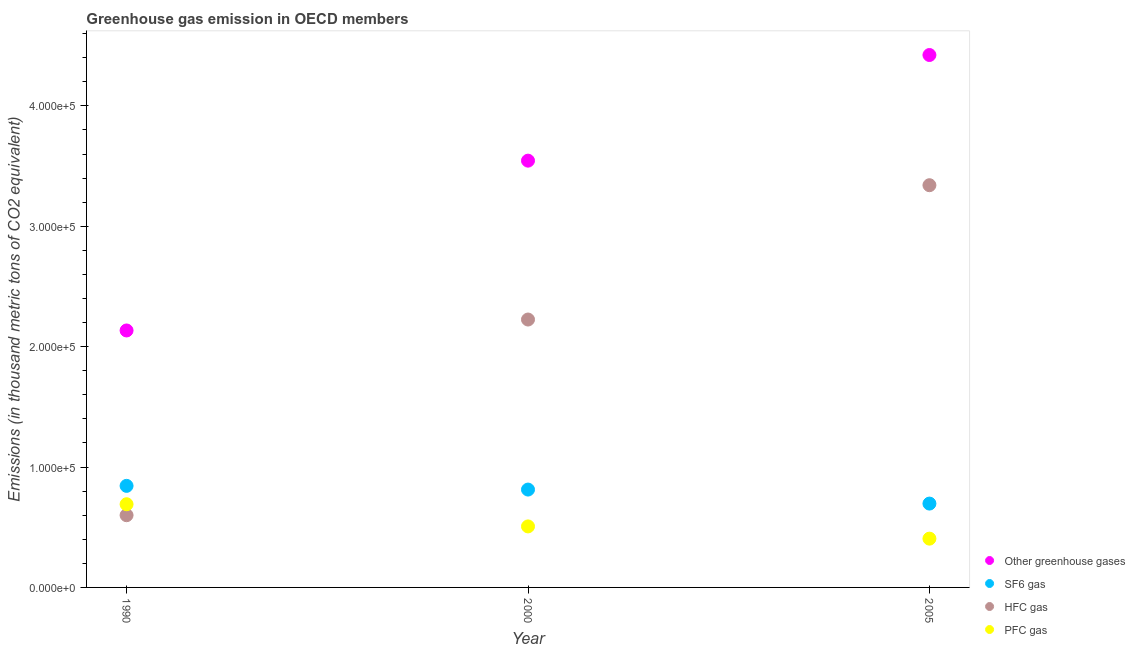What is the emission of greenhouse gases in 2000?
Your answer should be compact. 3.54e+05. Across all years, what is the maximum emission of greenhouse gases?
Your response must be concise. 4.42e+05. Across all years, what is the minimum emission of greenhouse gases?
Provide a succinct answer. 2.13e+05. In which year was the emission of pfc gas maximum?
Offer a terse response. 1990. What is the total emission of hfc gas in the graph?
Provide a succinct answer. 6.17e+05. What is the difference between the emission of hfc gas in 2000 and that in 2005?
Give a very brief answer. -1.12e+05. What is the difference between the emission of sf6 gas in 1990 and the emission of greenhouse gases in 2005?
Your answer should be very brief. -3.58e+05. What is the average emission of greenhouse gases per year?
Offer a terse response. 3.37e+05. In the year 1990, what is the difference between the emission of pfc gas and emission of hfc gas?
Provide a succinct answer. 9114.4. In how many years, is the emission of greenhouse gases greater than 280000 thousand metric tons?
Your answer should be compact. 2. What is the ratio of the emission of pfc gas in 1990 to that in 2005?
Offer a very short reply. 1.71. Is the difference between the emission of greenhouse gases in 1990 and 2005 greater than the difference between the emission of pfc gas in 1990 and 2005?
Your answer should be compact. No. What is the difference between the highest and the second highest emission of greenhouse gases?
Offer a very short reply. 8.78e+04. What is the difference between the highest and the lowest emission of greenhouse gases?
Your answer should be compact. 2.29e+05. Is it the case that in every year, the sum of the emission of greenhouse gases and emission of sf6 gas is greater than the sum of emission of pfc gas and emission of hfc gas?
Your response must be concise. Yes. How many dotlines are there?
Ensure brevity in your answer.  4. How many years are there in the graph?
Provide a succinct answer. 3. Are the values on the major ticks of Y-axis written in scientific E-notation?
Your answer should be very brief. Yes. Does the graph contain any zero values?
Ensure brevity in your answer.  No. Where does the legend appear in the graph?
Your answer should be very brief. Bottom right. What is the title of the graph?
Your answer should be very brief. Greenhouse gas emission in OECD members. Does "Methodology assessment" appear as one of the legend labels in the graph?
Keep it short and to the point. No. What is the label or title of the X-axis?
Make the answer very short. Year. What is the label or title of the Y-axis?
Make the answer very short. Emissions (in thousand metric tons of CO2 equivalent). What is the Emissions (in thousand metric tons of CO2 equivalent) in Other greenhouse gases in 1990?
Ensure brevity in your answer.  2.13e+05. What is the Emissions (in thousand metric tons of CO2 equivalent) in SF6 gas in 1990?
Make the answer very short. 8.44e+04. What is the Emissions (in thousand metric tons of CO2 equivalent) of HFC gas in 1990?
Provide a short and direct response. 6.00e+04. What is the Emissions (in thousand metric tons of CO2 equivalent) in PFC gas in 1990?
Ensure brevity in your answer.  6.91e+04. What is the Emissions (in thousand metric tons of CO2 equivalent) of Other greenhouse gases in 2000?
Give a very brief answer. 3.54e+05. What is the Emissions (in thousand metric tons of CO2 equivalent) of SF6 gas in 2000?
Keep it short and to the point. 8.13e+04. What is the Emissions (in thousand metric tons of CO2 equivalent) in HFC gas in 2000?
Offer a terse response. 2.23e+05. What is the Emissions (in thousand metric tons of CO2 equivalent) of PFC gas in 2000?
Keep it short and to the point. 5.07e+04. What is the Emissions (in thousand metric tons of CO2 equivalent) of Other greenhouse gases in 2005?
Offer a terse response. 4.42e+05. What is the Emissions (in thousand metric tons of CO2 equivalent) in SF6 gas in 2005?
Provide a short and direct response. 6.96e+04. What is the Emissions (in thousand metric tons of CO2 equivalent) in HFC gas in 2005?
Offer a very short reply. 3.34e+05. What is the Emissions (in thousand metric tons of CO2 equivalent) in PFC gas in 2005?
Make the answer very short. 4.05e+04. Across all years, what is the maximum Emissions (in thousand metric tons of CO2 equivalent) in Other greenhouse gases?
Make the answer very short. 4.42e+05. Across all years, what is the maximum Emissions (in thousand metric tons of CO2 equivalent) of SF6 gas?
Your response must be concise. 8.44e+04. Across all years, what is the maximum Emissions (in thousand metric tons of CO2 equivalent) in HFC gas?
Your answer should be compact. 3.34e+05. Across all years, what is the maximum Emissions (in thousand metric tons of CO2 equivalent) in PFC gas?
Keep it short and to the point. 6.91e+04. Across all years, what is the minimum Emissions (in thousand metric tons of CO2 equivalent) of Other greenhouse gases?
Provide a succinct answer. 2.13e+05. Across all years, what is the minimum Emissions (in thousand metric tons of CO2 equivalent) in SF6 gas?
Your answer should be compact. 6.96e+04. Across all years, what is the minimum Emissions (in thousand metric tons of CO2 equivalent) in HFC gas?
Provide a succinct answer. 6.00e+04. Across all years, what is the minimum Emissions (in thousand metric tons of CO2 equivalent) in PFC gas?
Your answer should be compact. 4.05e+04. What is the total Emissions (in thousand metric tons of CO2 equivalent) of Other greenhouse gases in the graph?
Your answer should be compact. 1.01e+06. What is the total Emissions (in thousand metric tons of CO2 equivalent) of SF6 gas in the graph?
Make the answer very short. 2.35e+05. What is the total Emissions (in thousand metric tons of CO2 equivalent) of HFC gas in the graph?
Your answer should be very brief. 6.17e+05. What is the total Emissions (in thousand metric tons of CO2 equivalent) of PFC gas in the graph?
Offer a very short reply. 1.60e+05. What is the difference between the Emissions (in thousand metric tons of CO2 equivalent) of Other greenhouse gases in 1990 and that in 2000?
Ensure brevity in your answer.  -1.41e+05. What is the difference between the Emissions (in thousand metric tons of CO2 equivalent) of SF6 gas in 1990 and that in 2000?
Offer a terse response. 3071.7. What is the difference between the Emissions (in thousand metric tons of CO2 equivalent) in HFC gas in 1990 and that in 2000?
Ensure brevity in your answer.  -1.63e+05. What is the difference between the Emissions (in thousand metric tons of CO2 equivalent) in PFC gas in 1990 and that in 2000?
Provide a succinct answer. 1.84e+04. What is the difference between the Emissions (in thousand metric tons of CO2 equivalent) in Other greenhouse gases in 1990 and that in 2005?
Your answer should be very brief. -2.29e+05. What is the difference between the Emissions (in thousand metric tons of CO2 equivalent) of SF6 gas in 1990 and that in 2005?
Your response must be concise. 1.47e+04. What is the difference between the Emissions (in thousand metric tons of CO2 equivalent) in HFC gas in 1990 and that in 2005?
Make the answer very short. -2.74e+05. What is the difference between the Emissions (in thousand metric tons of CO2 equivalent) in PFC gas in 1990 and that in 2005?
Give a very brief answer. 2.86e+04. What is the difference between the Emissions (in thousand metric tons of CO2 equivalent) of Other greenhouse gases in 2000 and that in 2005?
Provide a succinct answer. -8.78e+04. What is the difference between the Emissions (in thousand metric tons of CO2 equivalent) of SF6 gas in 2000 and that in 2005?
Your response must be concise. 1.16e+04. What is the difference between the Emissions (in thousand metric tons of CO2 equivalent) in HFC gas in 2000 and that in 2005?
Your answer should be very brief. -1.12e+05. What is the difference between the Emissions (in thousand metric tons of CO2 equivalent) in PFC gas in 2000 and that in 2005?
Ensure brevity in your answer.  1.02e+04. What is the difference between the Emissions (in thousand metric tons of CO2 equivalent) in Other greenhouse gases in 1990 and the Emissions (in thousand metric tons of CO2 equivalent) in SF6 gas in 2000?
Your answer should be compact. 1.32e+05. What is the difference between the Emissions (in thousand metric tons of CO2 equivalent) of Other greenhouse gases in 1990 and the Emissions (in thousand metric tons of CO2 equivalent) of HFC gas in 2000?
Offer a terse response. -9085.8. What is the difference between the Emissions (in thousand metric tons of CO2 equivalent) of Other greenhouse gases in 1990 and the Emissions (in thousand metric tons of CO2 equivalent) of PFC gas in 2000?
Make the answer very short. 1.63e+05. What is the difference between the Emissions (in thousand metric tons of CO2 equivalent) in SF6 gas in 1990 and the Emissions (in thousand metric tons of CO2 equivalent) in HFC gas in 2000?
Ensure brevity in your answer.  -1.38e+05. What is the difference between the Emissions (in thousand metric tons of CO2 equivalent) of SF6 gas in 1990 and the Emissions (in thousand metric tons of CO2 equivalent) of PFC gas in 2000?
Give a very brief answer. 3.37e+04. What is the difference between the Emissions (in thousand metric tons of CO2 equivalent) in HFC gas in 1990 and the Emissions (in thousand metric tons of CO2 equivalent) in PFC gas in 2000?
Your answer should be compact. 9302.6. What is the difference between the Emissions (in thousand metric tons of CO2 equivalent) in Other greenhouse gases in 1990 and the Emissions (in thousand metric tons of CO2 equivalent) in SF6 gas in 2005?
Provide a succinct answer. 1.44e+05. What is the difference between the Emissions (in thousand metric tons of CO2 equivalent) of Other greenhouse gases in 1990 and the Emissions (in thousand metric tons of CO2 equivalent) of HFC gas in 2005?
Your answer should be compact. -1.21e+05. What is the difference between the Emissions (in thousand metric tons of CO2 equivalent) in Other greenhouse gases in 1990 and the Emissions (in thousand metric tons of CO2 equivalent) in PFC gas in 2005?
Ensure brevity in your answer.  1.73e+05. What is the difference between the Emissions (in thousand metric tons of CO2 equivalent) in SF6 gas in 1990 and the Emissions (in thousand metric tons of CO2 equivalent) in HFC gas in 2005?
Give a very brief answer. -2.50e+05. What is the difference between the Emissions (in thousand metric tons of CO2 equivalent) in SF6 gas in 1990 and the Emissions (in thousand metric tons of CO2 equivalent) in PFC gas in 2005?
Keep it short and to the point. 4.38e+04. What is the difference between the Emissions (in thousand metric tons of CO2 equivalent) in HFC gas in 1990 and the Emissions (in thousand metric tons of CO2 equivalent) in PFC gas in 2005?
Offer a very short reply. 1.95e+04. What is the difference between the Emissions (in thousand metric tons of CO2 equivalent) of Other greenhouse gases in 2000 and the Emissions (in thousand metric tons of CO2 equivalent) of SF6 gas in 2005?
Give a very brief answer. 2.85e+05. What is the difference between the Emissions (in thousand metric tons of CO2 equivalent) in Other greenhouse gases in 2000 and the Emissions (in thousand metric tons of CO2 equivalent) in HFC gas in 2005?
Ensure brevity in your answer.  2.04e+04. What is the difference between the Emissions (in thousand metric tons of CO2 equivalent) of Other greenhouse gases in 2000 and the Emissions (in thousand metric tons of CO2 equivalent) of PFC gas in 2005?
Keep it short and to the point. 3.14e+05. What is the difference between the Emissions (in thousand metric tons of CO2 equivalent) in SF6 gas in 2000 and the Emissions (in thousand metric tons of CO2 equivalent) in HFC gas in 2005?
Offer a very short reply. -2.53e+05. What is the difference between the Emissions (in thousand metric tons of CO2 equivalent) of SF6 gas in 2000 and the Emissions (in thousand metric tons of CO2 equivalent) of PFC gas in 2005?
Your answer should be very brief. 4.08e+04. What is the difference between the Emissions (in thousand metric tons of CO2 equivalent) of HFC gas in 2000 and the Emissions (in thousand metric tons of CO2 equivalent) of PFC gas in 2005?
Offer a terse response. 1.82e+05. What is the average Emissions (in thousand metric tons of CO2 equivalent) in Other greenhouse gases per year?
Your answer should be very brief. 3.37e+05. What is the average Emissions (in thousand metric tons of CO2 equivalent) of SF6 gas per year?
Offer a terse response. 7.84e+04. What is the average Emissions (in thousand metric tons of CO2 equivalent) of HFC gas per year?
Provide a succinct answer. 2.06e+05. What is the average Emissions (in thousand metric tons of CO2 equivalent) of PFC gas per year?
Provide a succinct answer. 5.34e+04. In the year 1990, what is the difference between the Emissions (in thousand metric tons of CO2 equivalent) in Other greenhouse gases and Emissions (in thousand metric tons of CO2 equivalent) in SF6 gas?
Provide a succinct answer. 1.29e+05. In the year 1990, what is the difference between the Emissions (in thousand metric tons of CO2 equivalent) in Other greenhouse gases and Emissions (in thousand metric tons of CO2 equivalent) in HFC gas?
Provide a succinct answer. 1.53e+05. In the year 1990, what is the difference between the Emissions (in thousand metric tons of CO2 equivalent) of Other greenhouse gases and Emissions (in thousand metric tons of CO2 equivalent) of PFC gas?
Offer a very short reply. 1.44e+05. In the year 1990, what is the difference between the Emissions (in thousand metric tons of CO2 equivalent) of SF6 gas and Emissions (in thousand metric tons of CO2 equivalent) of HFC gas?
Keep it short and to the point. 2.44e+04. In the year 1990, what is the difference between the Emissions (in thousand metric tons of CO2 equivalent) of SF6 gas and Emissions (in thousand metric tons of CO2 equivalent) of PFC gas?
Make the answer very short. 1.53e+04. In the year 1990, what is the difference between the Emissions (in thousand metric tons of CO2 equivalent) in HFC gas and Emissions (in thousand metric tons of CO2 equivalent) in PFC gas?
Your response must be concise. -9114.4. In the year 2000, what is the difference between the Emissions (in thousand metric tons of CO2 equivalent) of Other greenhouse gases and Emissions (in thousand metric tons of CO2 equivalent) of SF6 gas?
Your answer should be very brief. 2.73e+05. In the year 2000, what is the difference between the Emissions (in thousand metric tons of CO2 equivalent) of Other greenhouse gases and Emissions (in thousand metric tons of CO2 equivalent) of HFC gas?
Offer a very short reply. 1.32e+05. In the year 2000, what is the difference between the Emissions (in thousand metric tons of CO2 equivalent) of Other greenhouse gases and Emissions (in thousand metric tons of CO2 equivalent) of PFC gas?
Your response must be concise. 3.04e+05. In the year 2000, what is the difference between the Emissions (in thousand metric tons of CO2 equivalent) in SF6 gas and Emissions (in thousand metric tons of CO2 equivalent) in HFC gas?
Make the answer very short. -1.41e+05. In the year 2000, what is the difference between the Emissions (in thousand metric tons of CO2 equivalent) in SF6 gas and Emissions (in thousand metric tons of CO2 equivalent) in PFC gas?
Provide a succinct answer. 3.06e+04. In the year 2000, what is the difference between the Emissions (in thousand metric tons of CO2 equivalent) in HFC gas and Emissions (in thousand metric tons of CO2 equivalent) in PFC gas?
Your answer should be compact. 1.72e+05. In the year 2005, what is the difference between the Emissions (in thousand metric tons of CO2 equivalent) in Other greenhouse gases and Emissions (in thousand metric tons of CO2 equivalent) in SF6 gas?
Ensure brevity in your answer.  3.73e+05. In the year 2005, what is the difference between the Emissions (in thousand metric tons of CO2 equivalent) of Other greenhouse gases and Emissions (in thousand metric tons of CO2 equivalent) of HFC gas?
Ensure brevity in your answer.  1.08e+05. In the year 2005, what is the difference between the Emissions (in thousand metric tons of CO2 equivalent) of Other greenhouse gases and Emissions (in thousand metric tons of CO2 equivalent) of PFC gas?
Your answer should be compact. 4.02e+05. In the year 2005, what is the difference between the Emissions (in thousand metric tons of CO2 equivalent) of SF6 gas and Emissions (in thousand metric tons of CO2 equivalent) of HFC gas?
Ensure brevity in your answer.  -2.64e+05. In the year 2005, what is the difference between the Emissions (in thousand metric tons of CO2 equivalent) of SF6 gas and Emissions (in thousand metric tons of CO2 equivalent) of PFC gas?
Your answer should be very brief. 2.91e+04. In the year 2005, what is the difference between the Emissions (in thousand metric tons of CO2 equivalent) of HFC gas and Emissions (in thousand metric tons of CO2 equivalent) of PFC gas?
Offer a very short reply. 2.94e+05. What is the ratio of the Emissions (in thousand metric tons of CO2 equivalent) of Other greenhouse gases in 1990 to that in 2000?
Give a very brief answer. 0.6. What is the ratio of the Emissions (in thousand metric tons of CO2 equivalent) of SF6 gas in 1990 to that in 2000?
Your answer should be compact. 1.04. What is the ratio of the Emissions (in thousand metric tons of CO2 equivalent) of HFC gas in 1990 to that in 2000?
Your answer should be compact. 0.27. What is the ratio of the Emissions (in thousand metric tons of CO2 equivalent) of PFC gas in 1990 to that in 2000?
Offer a terse response. 1.36. What is the ratio of the Emissions (in thousand metric tons of CO2 equivalent) of Other greenhouse gases in 1990 to that in 2005?
Give a very brief answer. 0.48. What is the ratio of the Emissions (in thousand metric tons of CO2 equivalent) of SF6 gas in 1990 to that in 2005?
Offer a terse response. 1.21. What is the ratio of the Emissions (in thousand metric tons of CO2 equivalent) of HFC gas in 1990 to that in 2005?
Make the answer very short. 0.18. What is the ratio of the Emissions (in thousand metric tons of CO2 equivalent) in PFC gas in 1990 to that in 2005?
Offer a terse response. 1.71. What is the ratio of the Emissions (in thousand metric tons of CO2 equivalent) in Other greenhouse gases in 2000 to that in 2005?
Make the answer very short. 0.8. What is the ratio of the Emissions (in thousand metric tons of CO2 equivalent) in SF6 gas in 2000 to that in 2005?
Provide a short and direct response. 1.17. What is the ratio of the Emissions (in thousand metric tons of CO2 equivalent) of HFC gas in 2000 to that in 2005?
Provide a succinct answer. 0.67. What is the ratio of the Emissions (in thousand metric tons of CO2 equivalent) of PFC gas in 2000 to that in 2005?
Ensure brevity in your answer.  1.25. What is the difference between the highest and the second highest Emissions (in thousand metric tons of CO2 equivalent) in Other greenhouse gases?
Provide a succinct answer. 8.78e+04. What is the difference between the highest and the second highest Emissions (in thousand metric tons of CO2 equivalent) in SF6 gas?
Keep it short and to the point. 3071.7. What is the difference between the highest and the second highest Emissions (in thousand metric tons of CO2 equivalent) of HFC gas?
Ensure brevity in your answer.  1.12e+05. What is the difference between the highest and the second highest Emissions (in thousand metric tons of CO2 equivalent) in PFC gas?
Offer a terse response. 1.84e+04. What is the difference between the highest and the lowest Emissions (in thousand metric tons of CO2 equivalent) in Other greenhouse gases?
Ensure brevity in your answer.  2.29e+05. What is the difference between the highest and the lowest Emissions (in thousand metric tons of CO2 equivalent) in SF6 gas?
Your answer should be very brief. 1.47e+04. What is the difference between the highest and the lowest Emissions (in thousand metric tons of CO2 equivalent) of HFC gas?
Offer a terse response. 2.74e+05. What is the difference between the highest and the lowest Emissions (in thousand metric tons of CO2 equivalent) in PFC gas?
Your answer should be very brief. 2.86e+04. 